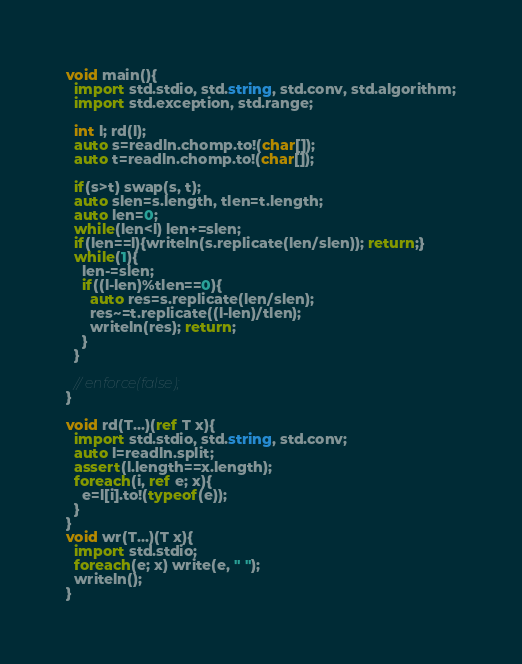<code> <loc_0><loc_0><loc_500><loc_500><_D_>void main(){
  import std.stdio, std.string, std.conv, std.algorithm;
  import std.exception, std.range;
  
  int l; rd(l);
  auto s=readln.chomp.to!(char[]);
  auto t=readln.chomp.to!(char[]);

  if(s>t) swap(s, t);
  auto slen=s.length, tlen=t.length;
  auto len=0;
  while(len<l) len+=slen;
  if(len==l){writeln(s.replicate(len/slen)); return;}
  while(1){
    len-=slen;
    if((l-len)%tlen==0){
      auto res=s.replicate(len/slen);
      res~=t.replicate((l-len)/tlen);
      writeln(res); return;
    }
  }

  // enforce(false);
}

void rd(T...)(ref T x){
  import std.stdio, std.string, std.conv;
  auto l=readln.split;
  assert(l.length==x.length);
  foreach(i, ref e; x){
    e=l[i].to!(typeof(e));
  }
}
void wr(T...)(T x){
  import std.stdio;
  foreach(e; x) write(e, " ");
  writeln();
}</code> 